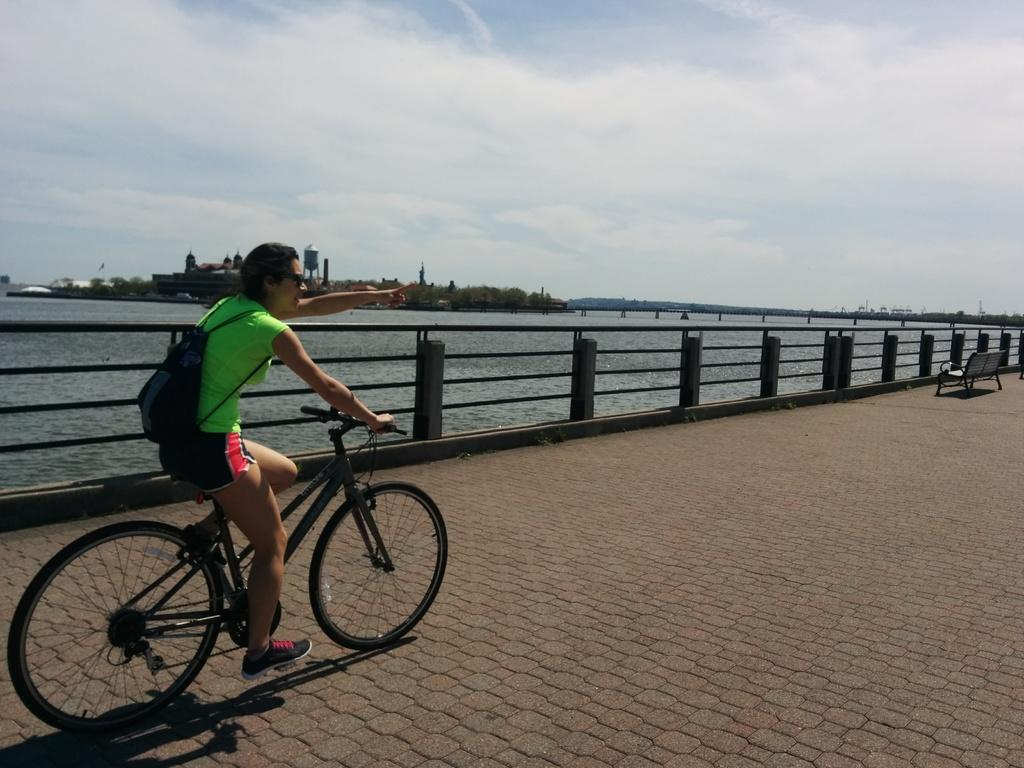Who is the main subject in the image? There is a woman in the image. What is the woman wearing? The woman is wearing a backpack. What is the woman doing in the image? The woman is riding a bicycle. What can be seen on the right side of the side of the image? There is a bench on the right side of the image. What is visible in the background of the image? There is a river, trees, buildings, and the sky in the background of the image. How many dinosaurs are visible in the image? There are no dinosaurs present in the image. What shape is the letter that the woman is holding in the image? The woman is not holding any letter in the image. 